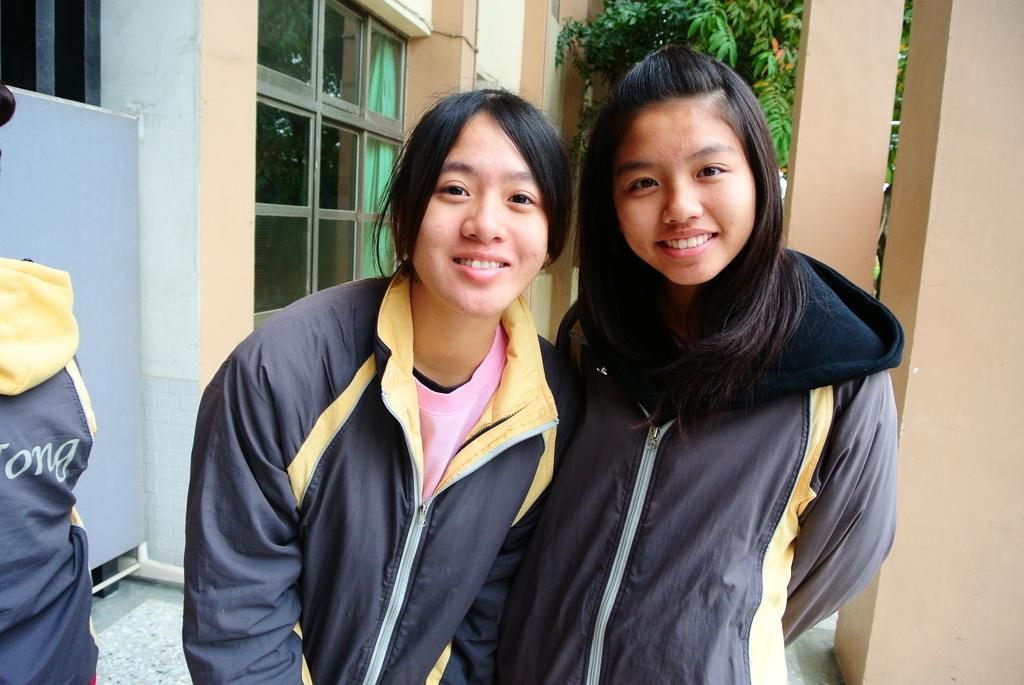Who or what can be seen in the image? There are people in the image. What natural element is present in the image? There is a tree in the image. What is on the left side of the image? There is a curtain on the left side of the image. What architectural feature is visible in the image? There is a window in the image. What type of plantation can be seen in the image? There is no plantation present in the image. 